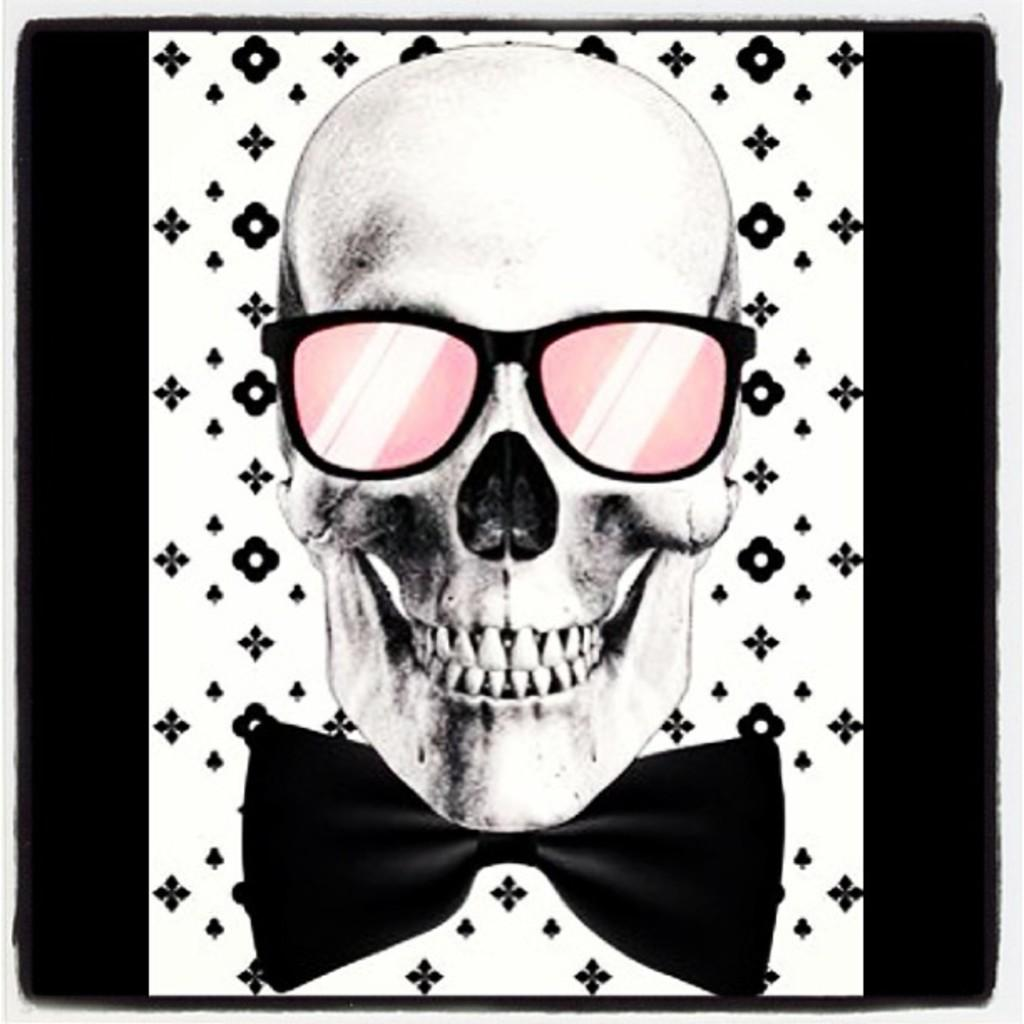What is the main subject of the image? The main subject of the image is a picture of a skull. What is the skull wearing in the image? The skull is wearing glasses in the image. What type of mouth does the skull have in the image? The image does not show the skull having a mouth, as it is a picture of a skull without any additional features. 